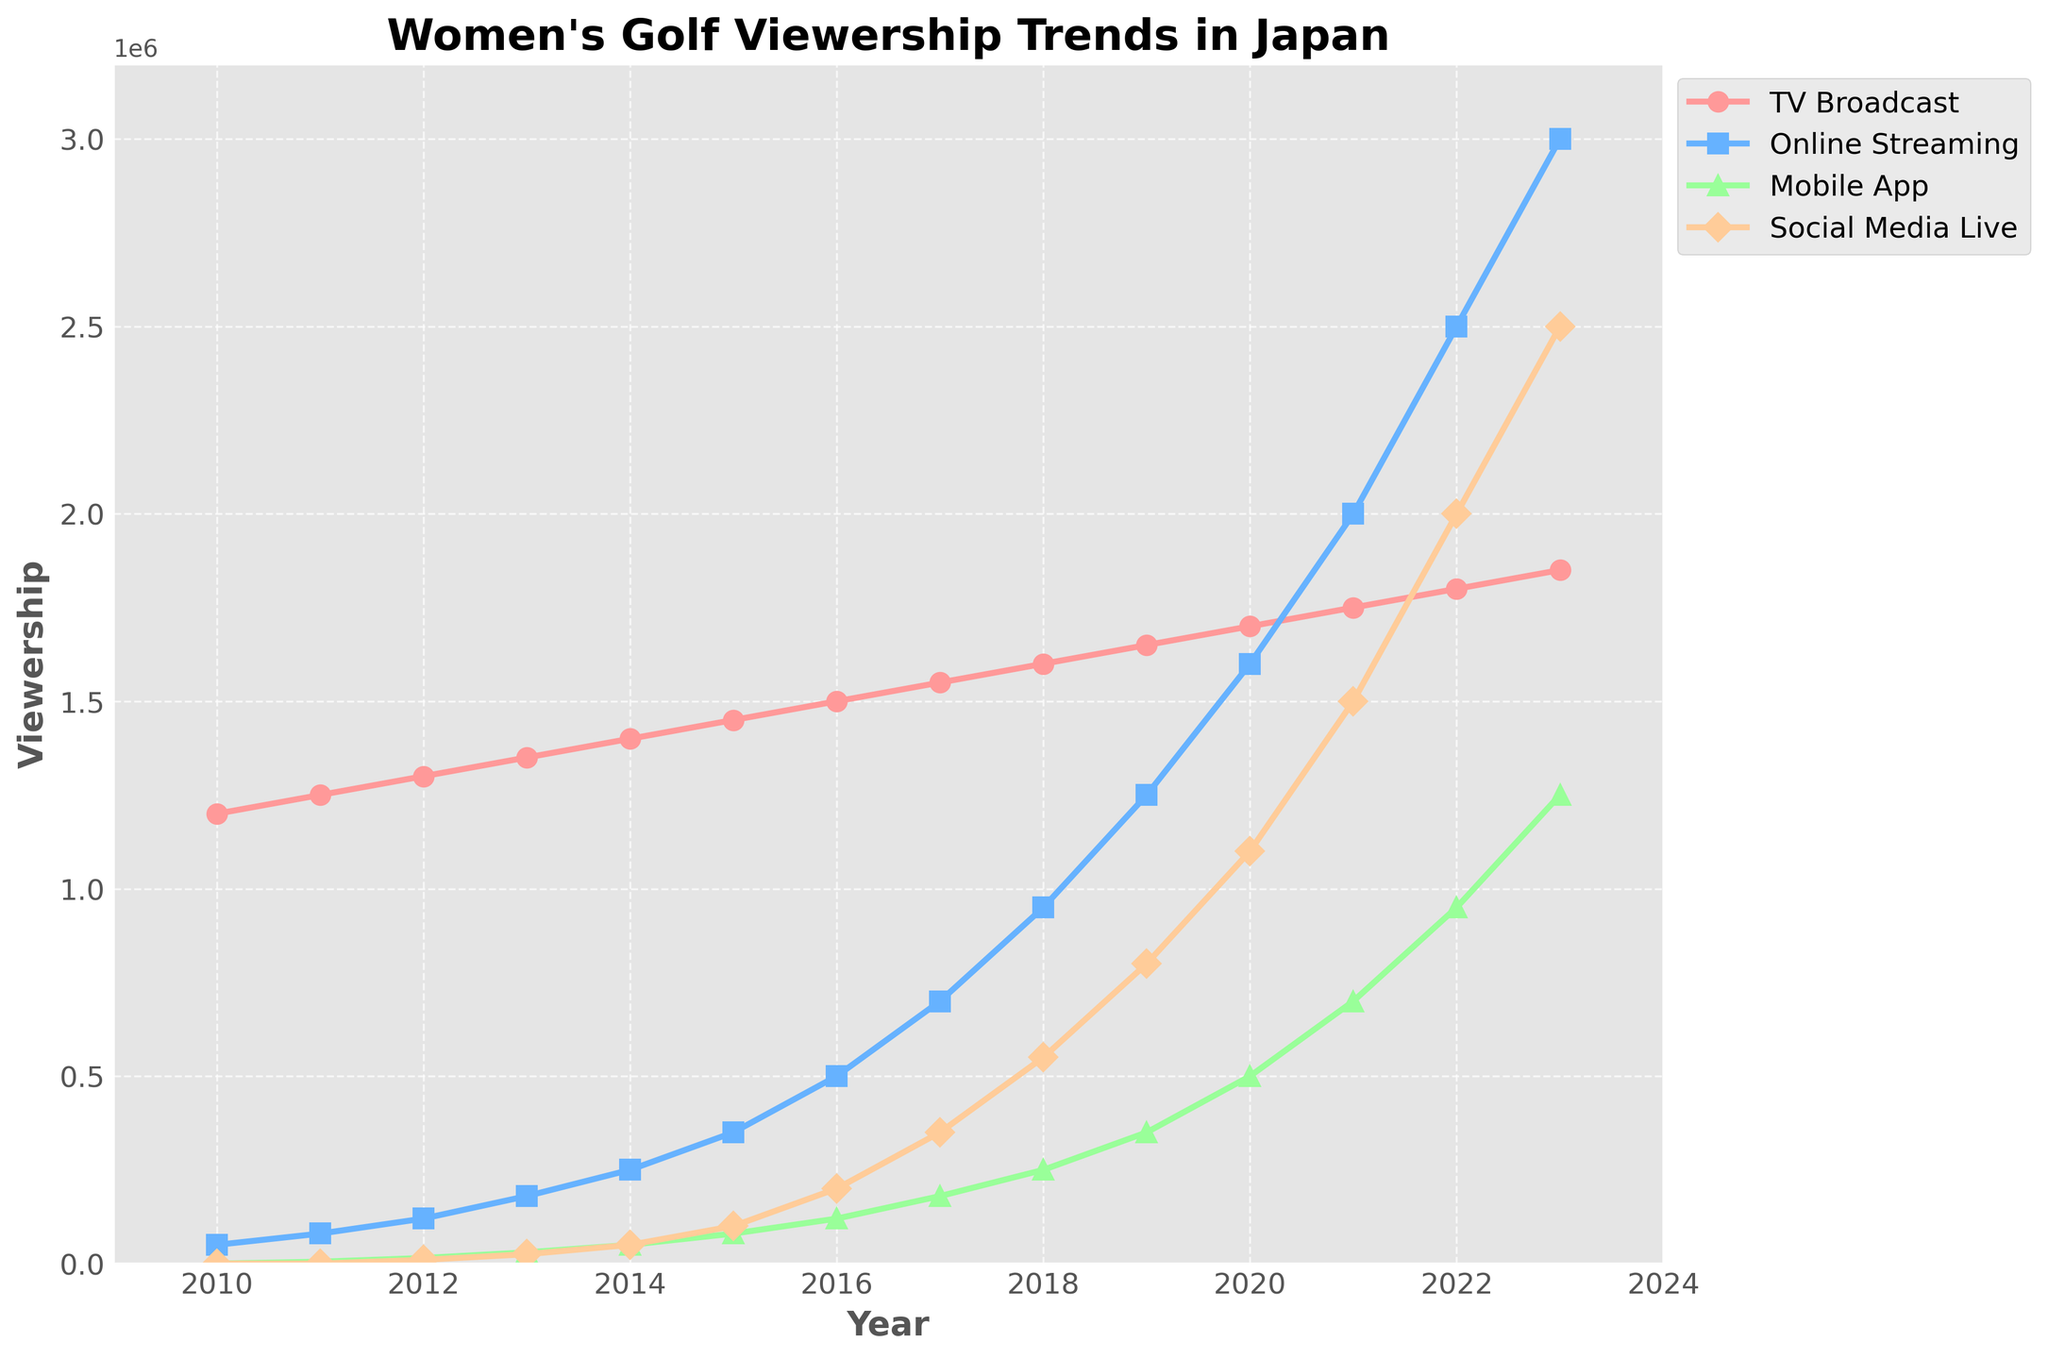Which platform had the highest viewership in 2023? From the figure, observe the lines representing each platform in the year 2023. The "Online Streaming" line reaches the highest point compared to the other platforms.
Answer: Online Streaming In which year did Social Media Live first surpass 500,000 viewers? Look at the line representing "Social Media Live" and identify the year where the value first exceeds 500,000. The first occurrence is in 2018.
Answer: 2018 By how much did TV Broadcast viewership increase from 2010 to 2023? Find the values for TV Broadcast in the years 2010 and 2023. The increase is calculated by subtracting the 2010 value from the 2023 value: 1,850,000 - 1,200,000 = 650,000.
Answer: 650,000 Which platform saw the most significant increase in viewership between 2020 and 2023? Calculate the difference in viewership for each platform from 2020 to 2023. The most significant increase is for "Online Streaming" with an increase of 3,000,000 - 1,600,000 = 1,400,000.
Answer: Online Streaming What was the average viewership for Mobile App over the period 2010 to 2023? Sum the viewership numbers for Mobile App from 2010 to 2023 and divide by the total number of years (14). (0 + 5,000 + 15,000 + 30,000 + 50,000 + 80,000 + 120,000 + 180,000 + 250,000 + 350,000 + 500,000 + 700,000 + 950,000 + 1,250,000) / 14 = 215,714.29.
Answer: 215,714.29 Did TV Broadcast viewership ever decline from one year to the next? Check the trend line for TV Broadcast to see if it ever decreases from one point to the next. The TV Broadcast viewership shows a consistent increase each year without decline.
Answer: No What is the difference in viewership between TV Broadcast and Social Media Live in 2021? Identify the viewership numbers for TV Broadcast and Social Media Live in 2021. Then subtract the Social Media Live viewership from the TV Broadcast viewership: 1,750,000 - 1,500,000 = 250,000.
Answer: 250,000 How many times did Online Streaming viewership double compared to the previous year? Starting from 2010, check each year to see if Online Streaming viewership doubled compared to the previous year: 2011 (No), 2012 (Yes), 2013 (Yes), 2014 (No), 2015 (Yes), 2016 (Yes), 2017 (No), 2018 (Yes), 2019 (Yes), 2020 (Yes), 2021 (Yes), 2022 (Yes). Count the years: 8 times.
Answer: 8 